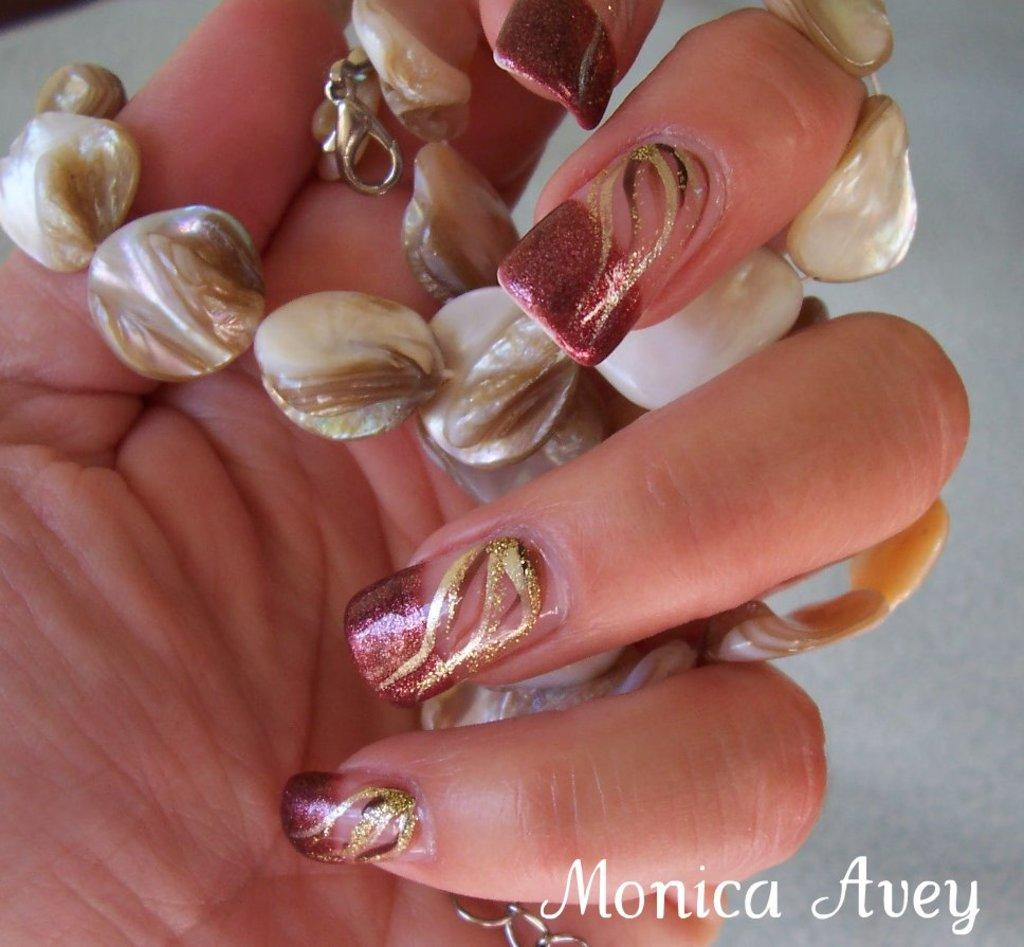<image>
Present a compact description of the photo's key features. Monica Avey is the stamped watermark on the photo. 